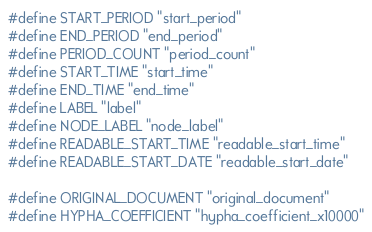<code> <loc_0><loc_0><loc_500><loc_500><_C++_>#define START_PERIOD "start_period"
#define END_PERIOD "end_period"
#define PERIOD_COUNT "period_count"
#define START_TIME "start_time"
#define END_TIME "end_time"
#define LABEL "label"
#define NODE_LABEL "node_label"
#define READABLE_START_TIME "readable_start_time"
#define READABLE_START_DATE "readable_start_date"

#define ORIGINAL_DOCUMENT "original_document"
#define HYPHA_COEFFICIENT "hypha_coefficient_x10000"</code> 